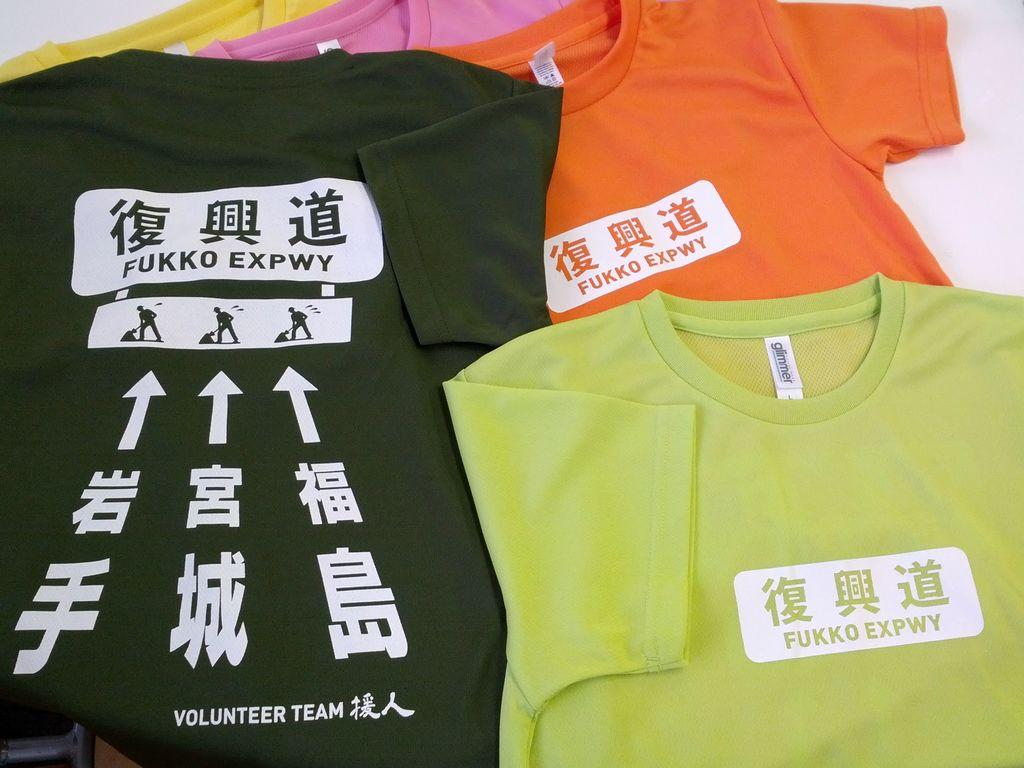What types of clothing items are in the image? There are shirts of different colors in the image. Can you describe the shirt in the top left corner? There is a yellow shirt in the top left corner. What is on top of the yellow shirt? There is a pink shirt on top of the yellow shirt. What is on top of the pink shirt? There is a black shirt on top of the pink shirt. Can you describe another shirt in the image? There is a green shirt in the image, and it is on top of an orange shirt. Where is the kitten playing with a spot in the image? There is no kitten or spot present in the image; it only features shirts of different colors. 